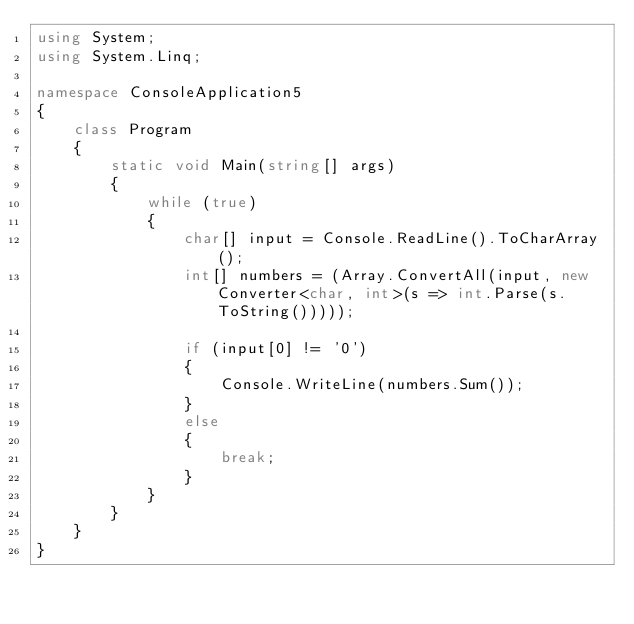<code> <loc_0><loc_0><loc_500><loc_500><_C#_>using System;
using System.Linq;

namespace ConsoleApplication5
{
    class Program
    {
        static void Main(string[] args)
        {
            while (true)
            {
                char[] input = Console.ReadLine().ToCharArray();
                int[] numbers = (Array.ConvertAll(input, new Converter<char, int>(s => int.Parse(s.ToString()))));

                if (input[0] != '0')
                {
                    Console.WriteLine(numbers.Sum());
                }
                else
                {
                    break;
                }
            }
        }
    }
}</code> 